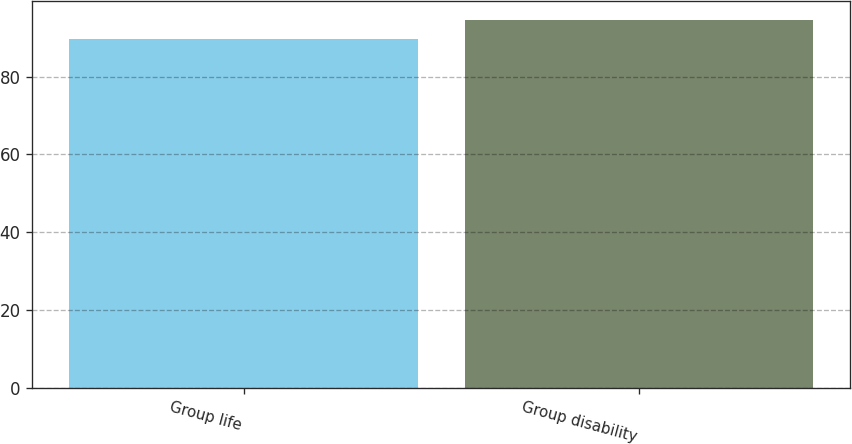Convert chart. <chart><loc_0><loc_0><loc_500><loc_500><bar_chart><fcel>Group life<fcel>Group disability<nl><fcel>89.7<fcel>94.7<nl></chart> 